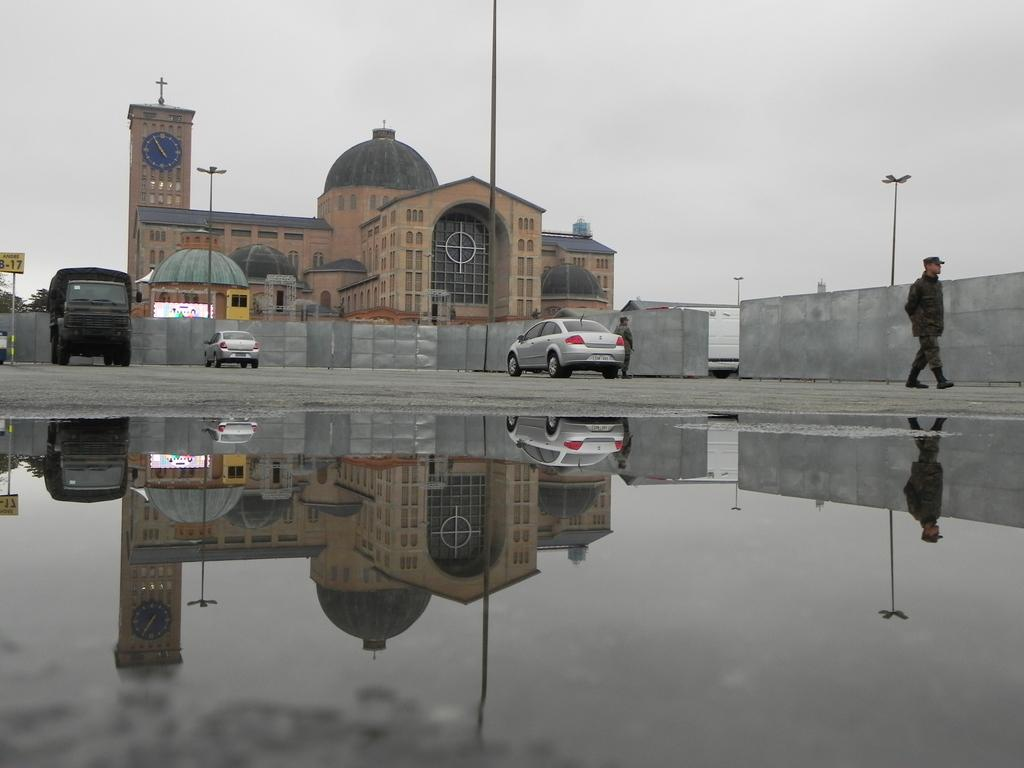What can be seen in the image related to transportation? There are vehicles parked in the image. How many people are present in the image? There are two persons standing in the image. What is visible in the background of the image? There is a building visible in the background of the image. What is the condition of the sky in the image? The sky is clear in the image. What type of bottle is being used for treatment in the image? There is no bottle or treatment present in the image. How is the cable connected to the vehicles in the image? There is no cable present in the image; it only shows vehicles parked and two persons standing. 